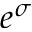Convert formula to latex. <formula><loc_0><loc_0><loc_500><loc_500>e ^ { \sigma }</formula> 